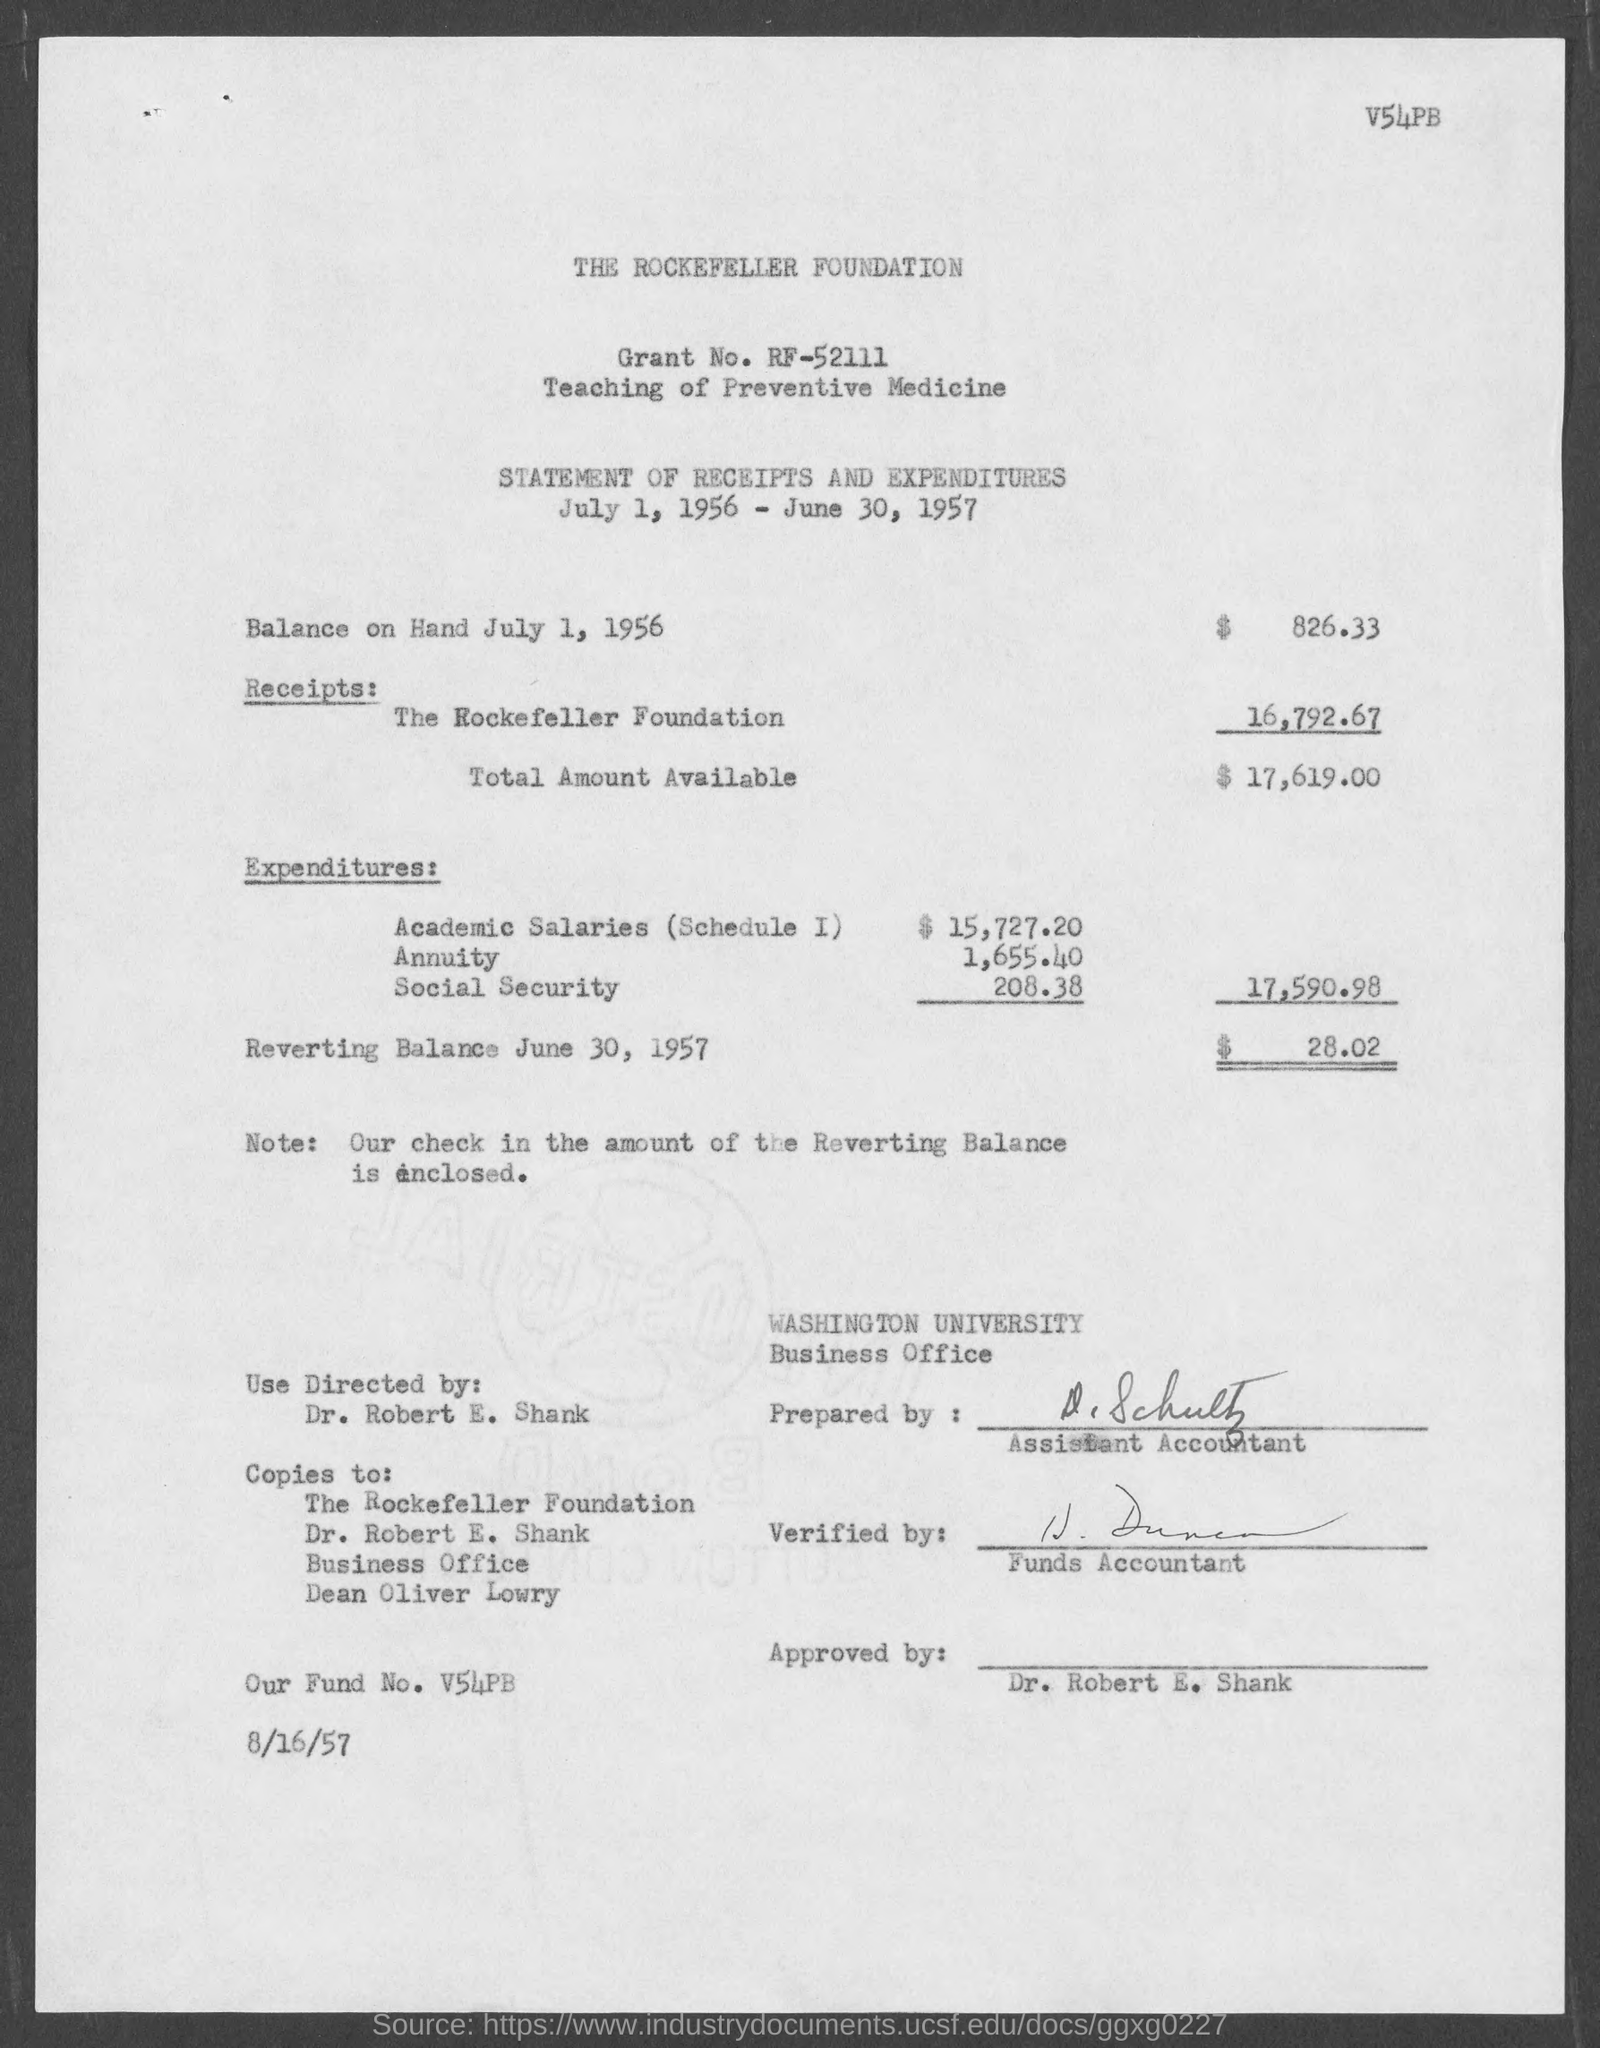Highlight a few significant elements in this photo. On July 1, 1956, the balance on hand was $826.33. The grant number is RF-52111. The total amount available is $17,619.00. 